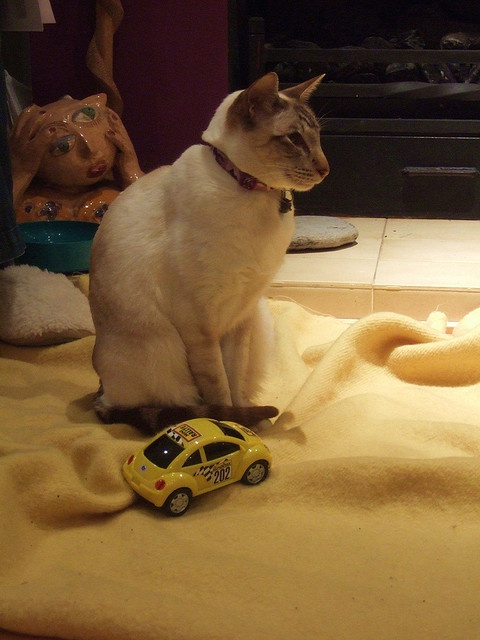Describe the objects in this image and their specific colors. I can see bed in black, olive, tan, and khaki tones, cat in black, brown, olive, gray, and maroon tones, and car in black and olive tones in this image. 